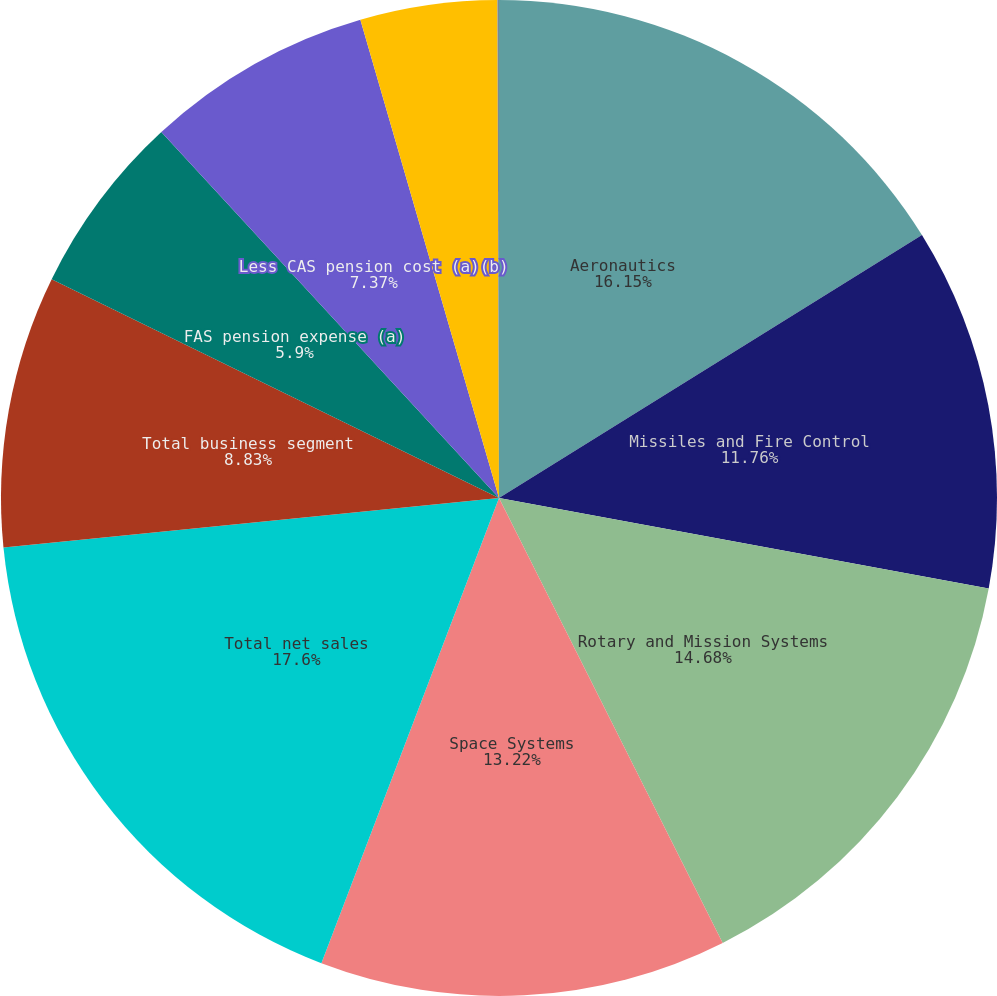<chart> <loc_0><loc_0><loc_500><loc_500><pie_chart><fcel>Aeronautics<fcel>Missiles and Fire Control<fcel>Rotary and Mission Systems<fcel>Space Systems<fcel>Total net sales<fcel>Total business segment<fcel>FAS pension expense (a)<fcel>Less CAS pension cost (a)(b)<fcel>FAS/CAS pension adjustment (c)<fcel>Stock-based compensation<nl><fcel>16.15%<fcel>11.76%<fcel>14.68%<fcel>13.22%<fcel>17.61%<fcel>8.83%<fcel>5.9%<fcel>7.37%<fcel>4.44%<fcel>0.05%<nl></chart> 